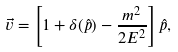Convert formula to latex. <formula><loc_0><loc_0><loc_500><loc_500>\vec { v } = \left [ 1 + \delta ( \hat { p } ) - \frac { m ^ { 2 } } { 2 E ^ { 2 } } \right ] \hat { p } ,</formula> 